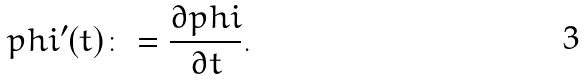Convert formula to latex. <formula><loc_0><loc_0><loc_500><loc_500>p h i ^ { \prime } ( t ) \colon = \frac { \partial p h i } { \partial t } .</formula> 